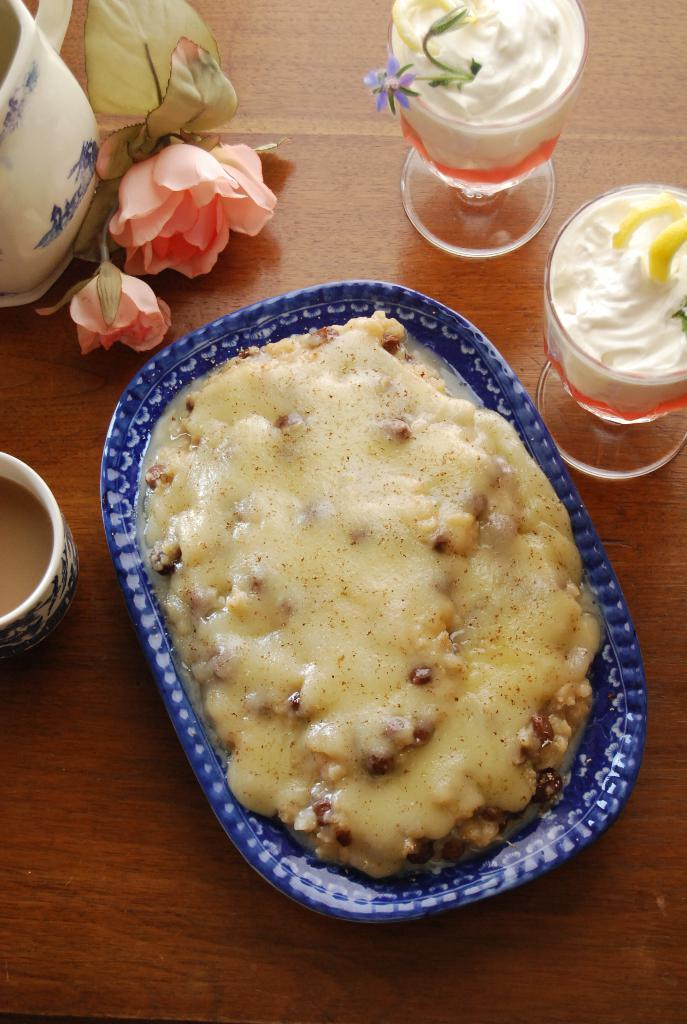What type of surface is visible in the image? There is a wooden surface in the image. What is on the wooden surface? There is a food item on a plate in the image. What type of containers are present in the image? There are glasses and a cup in the image. What type of decoration is present in the image? There are flowers in the image. What object is located in the top left corner of the image? There is an object in the top left corner of the image. What type of invention is being demonstrated in the image? There is no invention being demonstrated in the image; it features a wooden surface with various objects on it. What type of meat is being served on the plate in the image? There is no meat present in the image; the food item on the plate is not specified. 